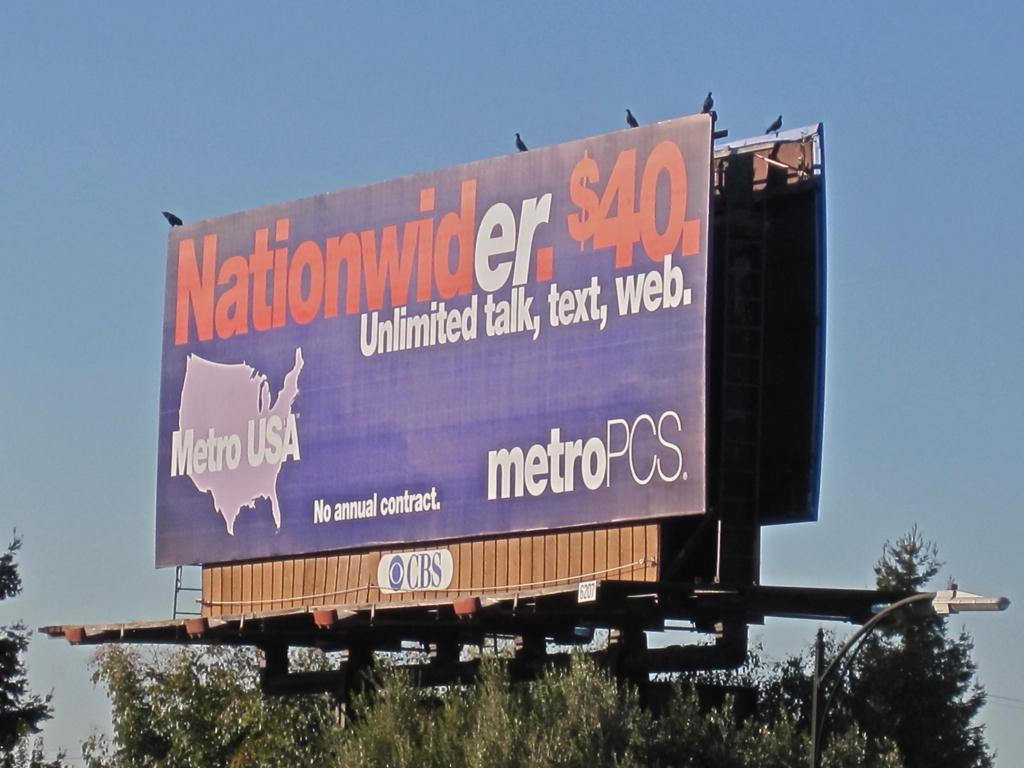<image>
Present a compact description of the photo's key features. A billboard sign from Metro PCS USA advertising. 